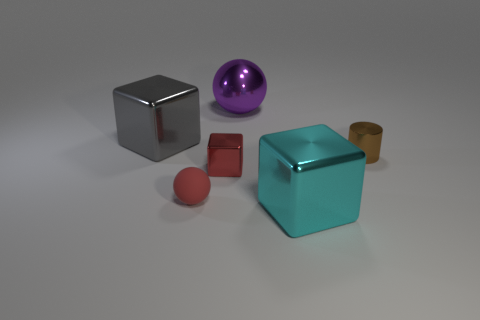There is a sphere that is to the right of the sphere that is in front of the big shiny cube left of the purple metal sphere; what is it made of?
Keep it short and to the point. Metal. Does the metal object that is right of the cyan metal object have the same size as the tiny red rubber object?
Provide a succinct answer. Yes. There is a big thing behind the gray metal cube; what is its material?
Provide a succinct answer. Metal. Is the number of shiny balls greater than the number of small yellow matte things?
Ensure brevity in your answer.  Yes. What number of objects are either cubes that are in front of the red ball or big cyan metal things?
Keep it short and to the point. 1. There is a big thing in front of the large gray object; what number of small shiny objects are on the left side of it?
Provide a short and direct response. 1. What is the size of the cube that is behind the small shiny thing that is right of the big thing in front of the gray object?
Make the answer very short. Large. There is a big object in front of the small brown cylinder; is it the same color as the tiny rubber thing?
Provide a succinct answer. No. The gray thing that is the same shape as the tiny red metal object is what size?
Provide a short and direct response. Large. What number of things are either big things that are on the left side of the tiny red rubber thing or big objects in front of the red shiny thing?
Your answer should be very brief. 2. 